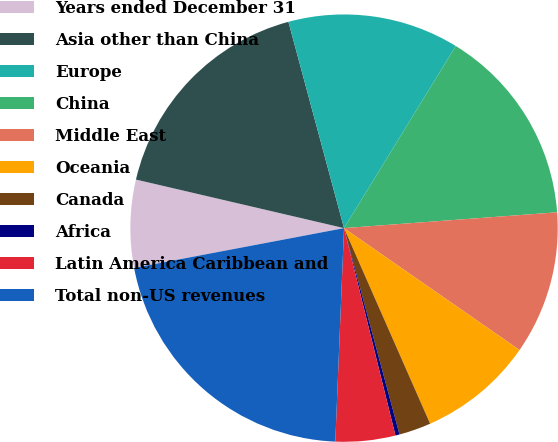Convert chart to OTSL. <chart><loc_0><loc_0><loc_500><loc_500><pie_chart><fcel>Years ended December 31<fcel>Asia other than China<fcel>Europe<fcel>China<fcel>Middle East<fcel>Oceania<fcel>Canada<fcel>Africa<fcel>Latin America Caribbean and<fcel>Total non-US revenues<nl><fcel>6.63%<fcel>17.16%<fcel>12.95%<fcel>15.06%<fcel>10.84%<fcel>8.74%<fcel>2.42%<fcel>0.31%<fcel>4.52%<fcel>21.37%<nl></chart> 